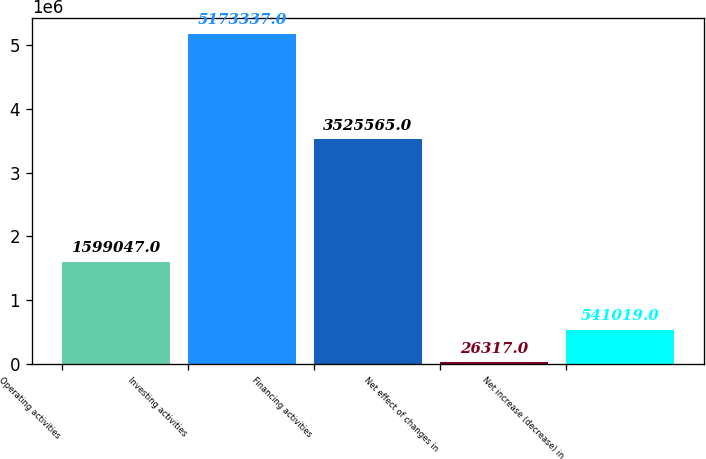Convert chart to OTSL. <chart><loc_0><loc_0><loc_500><loc_500><bar_chart><fcel>Operating activities<fcel>Investing activities<fcel>Financing activities<fcel>Net effect of changes in<fcel>Net increase (decrease) in<nl><fcel>1.59905e+06<fcel>5.17334e+06<fcel>3.52556e+06<fcel>26317<fcel>541019<nl></chart> 